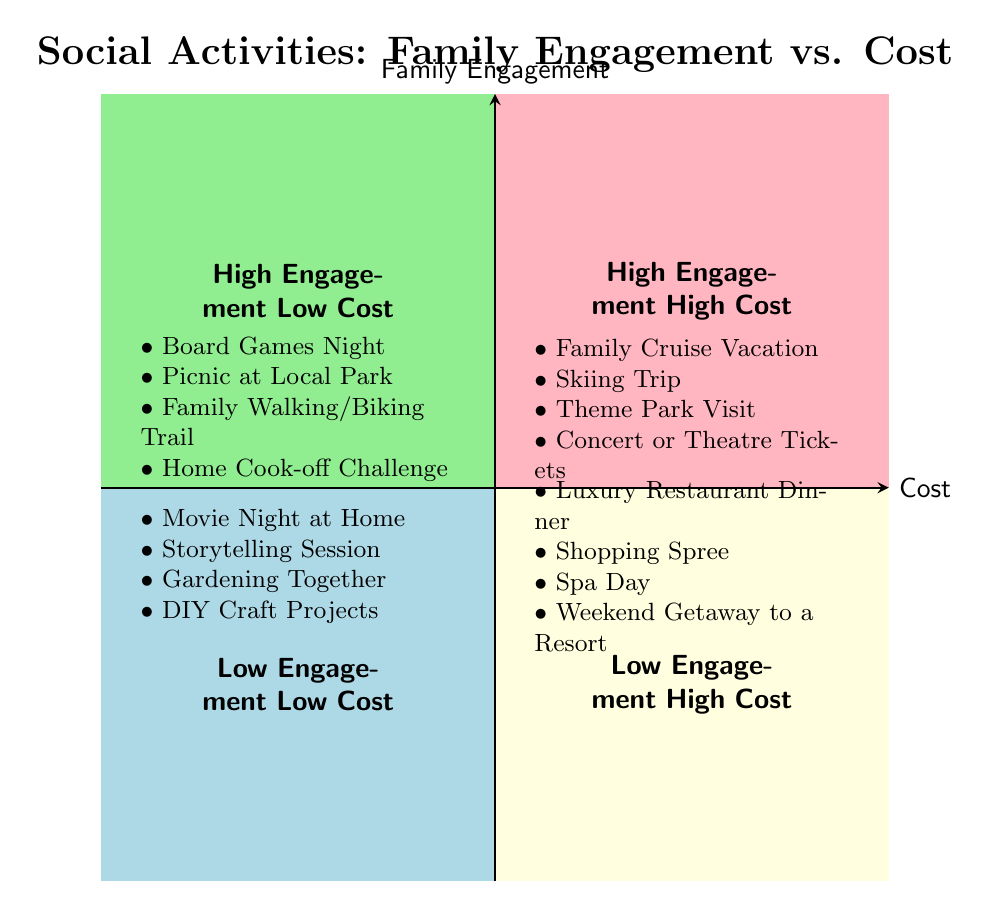What activities are listed for High Family Engagement and Low Cost? Referring to the quadrant labeled "High Engagement Low Cost," the listed activities are shown directly under this label in the diagram. They include Board Games Night, Picnic at Local Park, Family Walking/Biking Trail, and Home Cook-off Challenge.
Answer: Board Games Night, Picnic at Local Park, Family Walking/Biking Trail, Home Cook-off Challenge How many activities are in the Low Engagement Low Cost quadrant? In the quadrant labeled "Low Engagement Low Cost," there are four activities listed: Movie Night at Home, Storytelling Session, Gardening Together, and DIY Craft Projects. Counting these gives a total of four.
Answer: 4 What is an example of an activity with High Family Engagement and High Cost? In the "High Engagement High Cost" quadrant, activities are listed, such as Family Cruise Vacation, Skiing Trip, Theme Park Visit, and Concert or Theatre Tickets. Each of these activities reflects high family engagement combined with high costs. One example is Family Cruise Vacation.
Answer: Family Cruise Vacation Which quadrant has the least family engagement? The quadrant labeled "Low Engagement Low Cost" represents the least amount of family engagement based on the axes of the diagram. This designation is clear from the labeling of the quadrants.
Answer: Low Engagement Low Cost How do activities in Low Engagement and High Cost compare to High Engagement and Low Cost? Activities in "Low Engagement High Cost" are typically more expensive and offer less family engagement than those in "High Engagement Low Cost." This difference in engagement level affects the overall experience families may have, with higher cost in the less engaging activities potentially leading to different expectations or interactions.
Answer: Less engaging activities are more expensive 